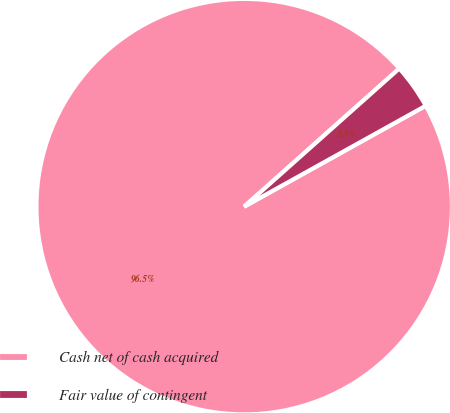<chart> <loc_0><loc_0><loc_500><loc_500><pie_chart><fcel>Cash net of cash acquired<fcel>Fair value of contingent<nl><fcel>96.49%<fcel>3.51%<nl></chart> 